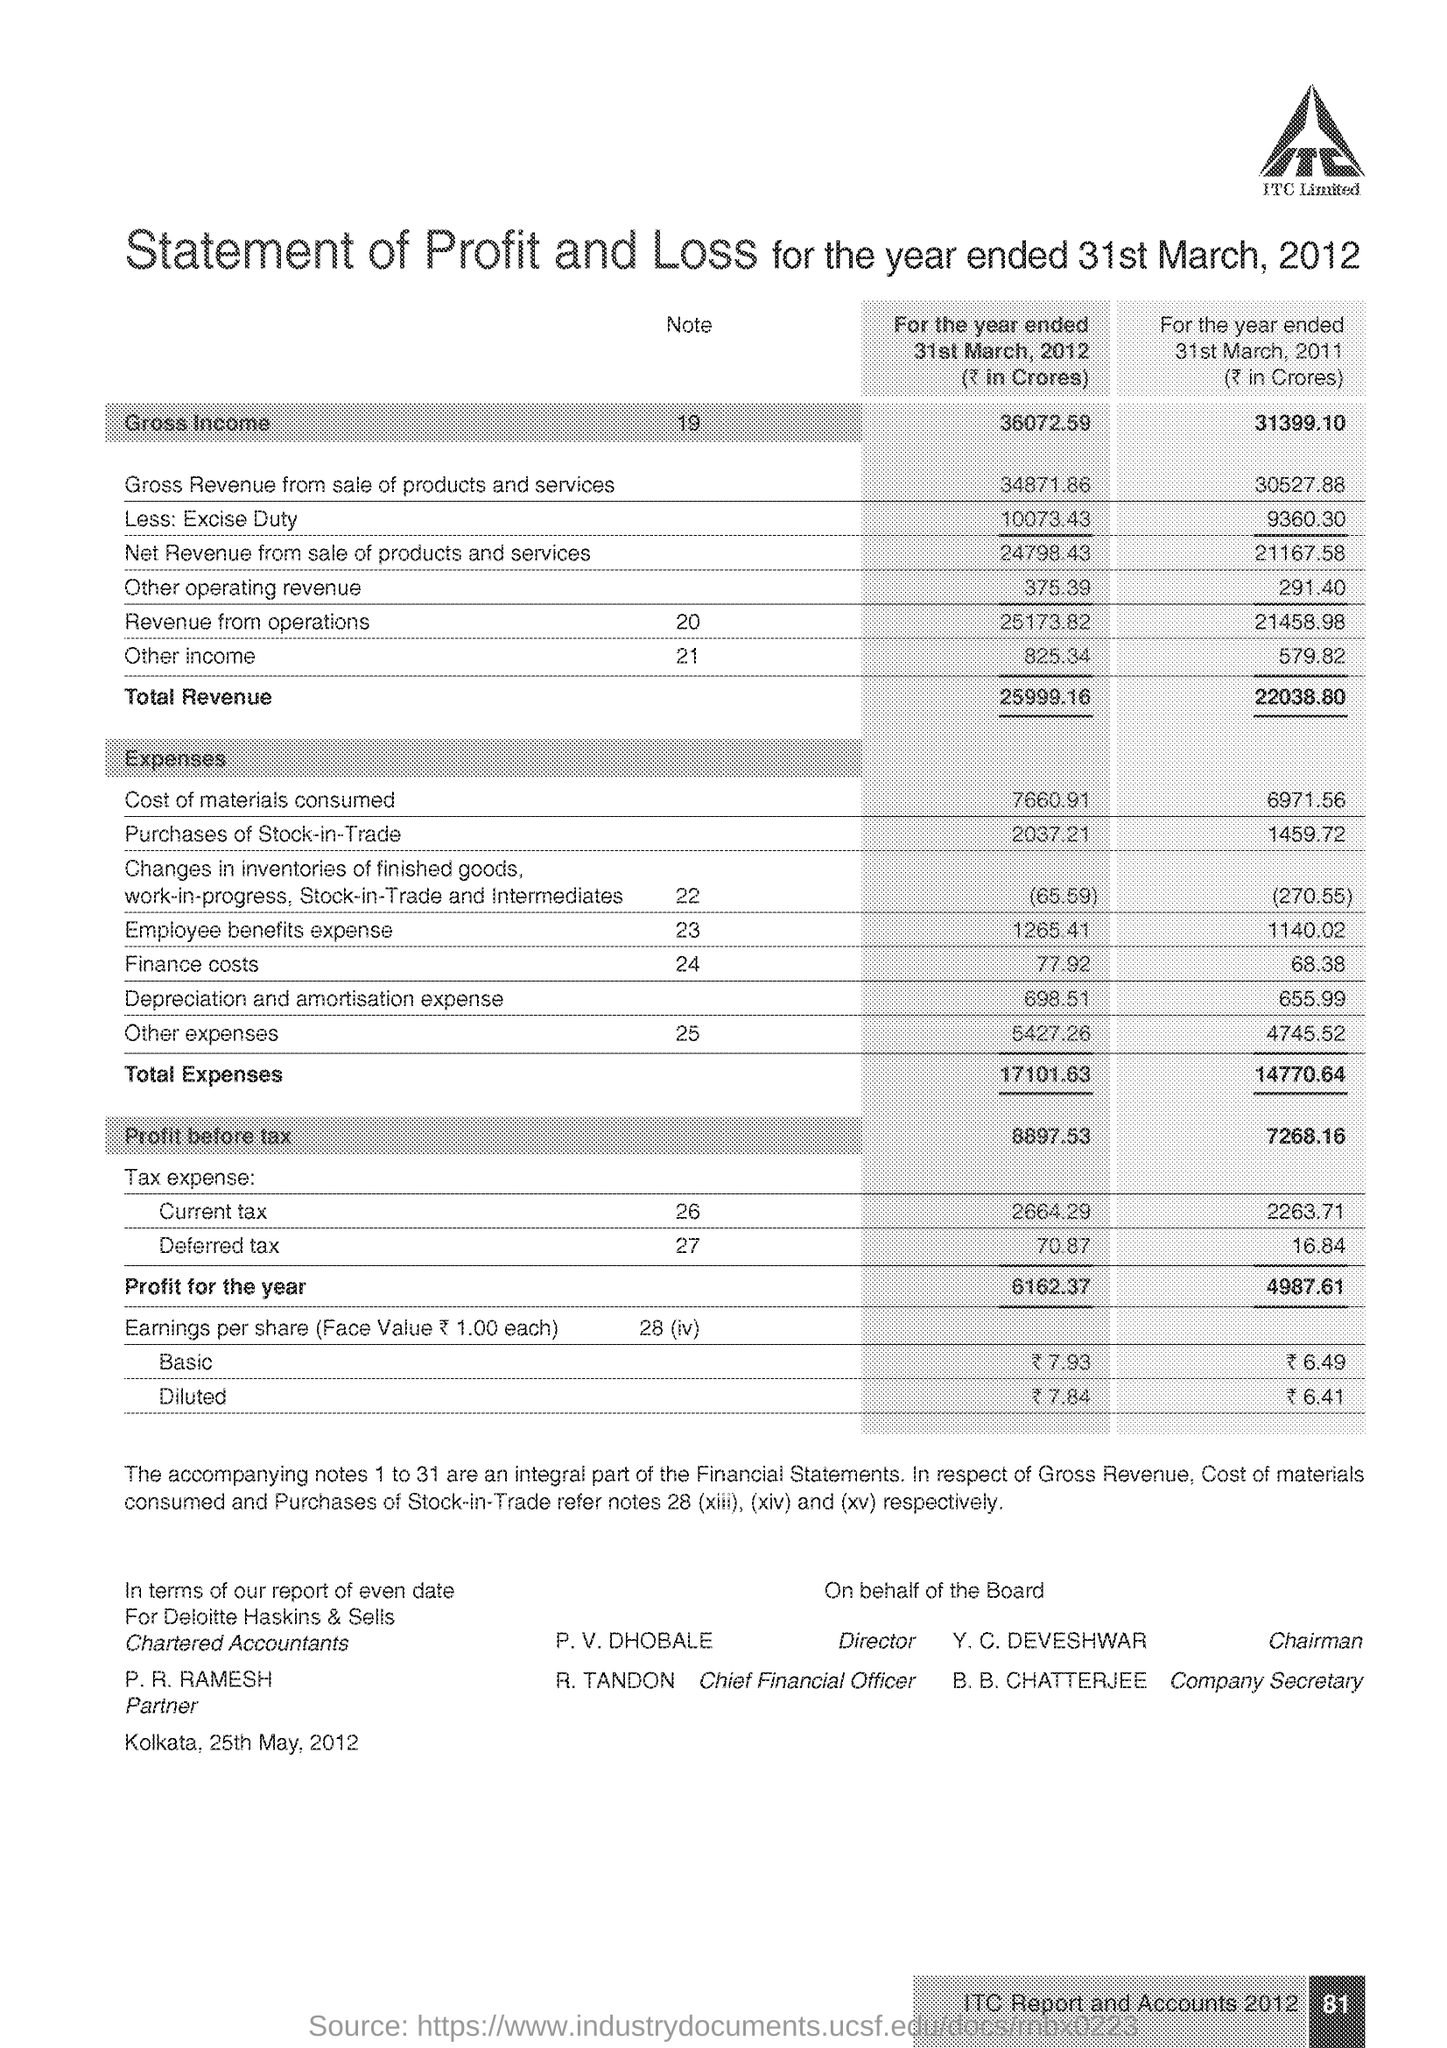What is the amount of total expenses at the end of 31st March 2012?
Offer a very short reply. 17101.63. What is the amount of total expenses at the end of 31st March 2011?
Make the answer very short. 14770.64. What is the amount of total revenue at the end of 31st March 2011?
Offer a very short reply. 22038.80. What is the amount of total of Gross Income at the end of 31st March 2012?
Offer a very short reply. 36072.59. What is the amount of total of Gross Income at the end of 31st March 2011?
Your answer should be very brief. 31399.10. 